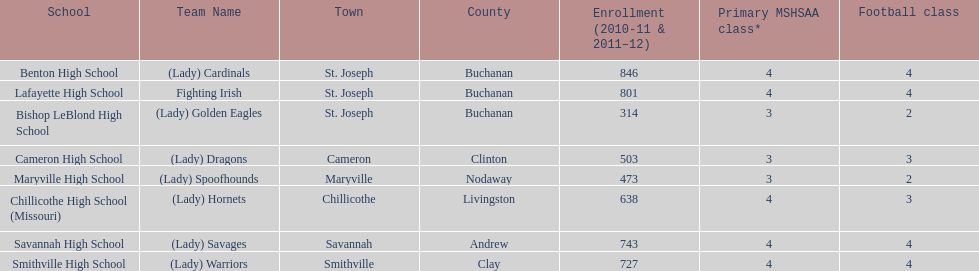How many of the schools had at least 500 students enrolled in the 2010-2011 and 2011-2012 season? 6. 